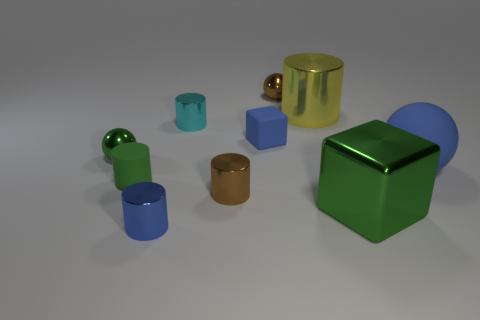Subtract all small brown metal cylinders. How many cylinders are left? 4 Subtract all blue blocks. How many blocks are left? 1 Subtract all blocks. How many objects are left? 8 Subtract 1 cylinders. How many cylinders are left? 4 Subtract all blue blocks. Subtract all big rubber spheres. How many objects are left? 8 Add 3 large yellow cylinders. How many large yellow cylinders are left? 4 Add 7 green metallic things. How many green metallic things exist? 9 Subtract 1 brown spheres. How many objects are left? 9 Subtract all gray cylinders. Subtract all yellow balls. How many cylinders are left? 5 Subtract all gray balls. How many green cylinders are left? 1 